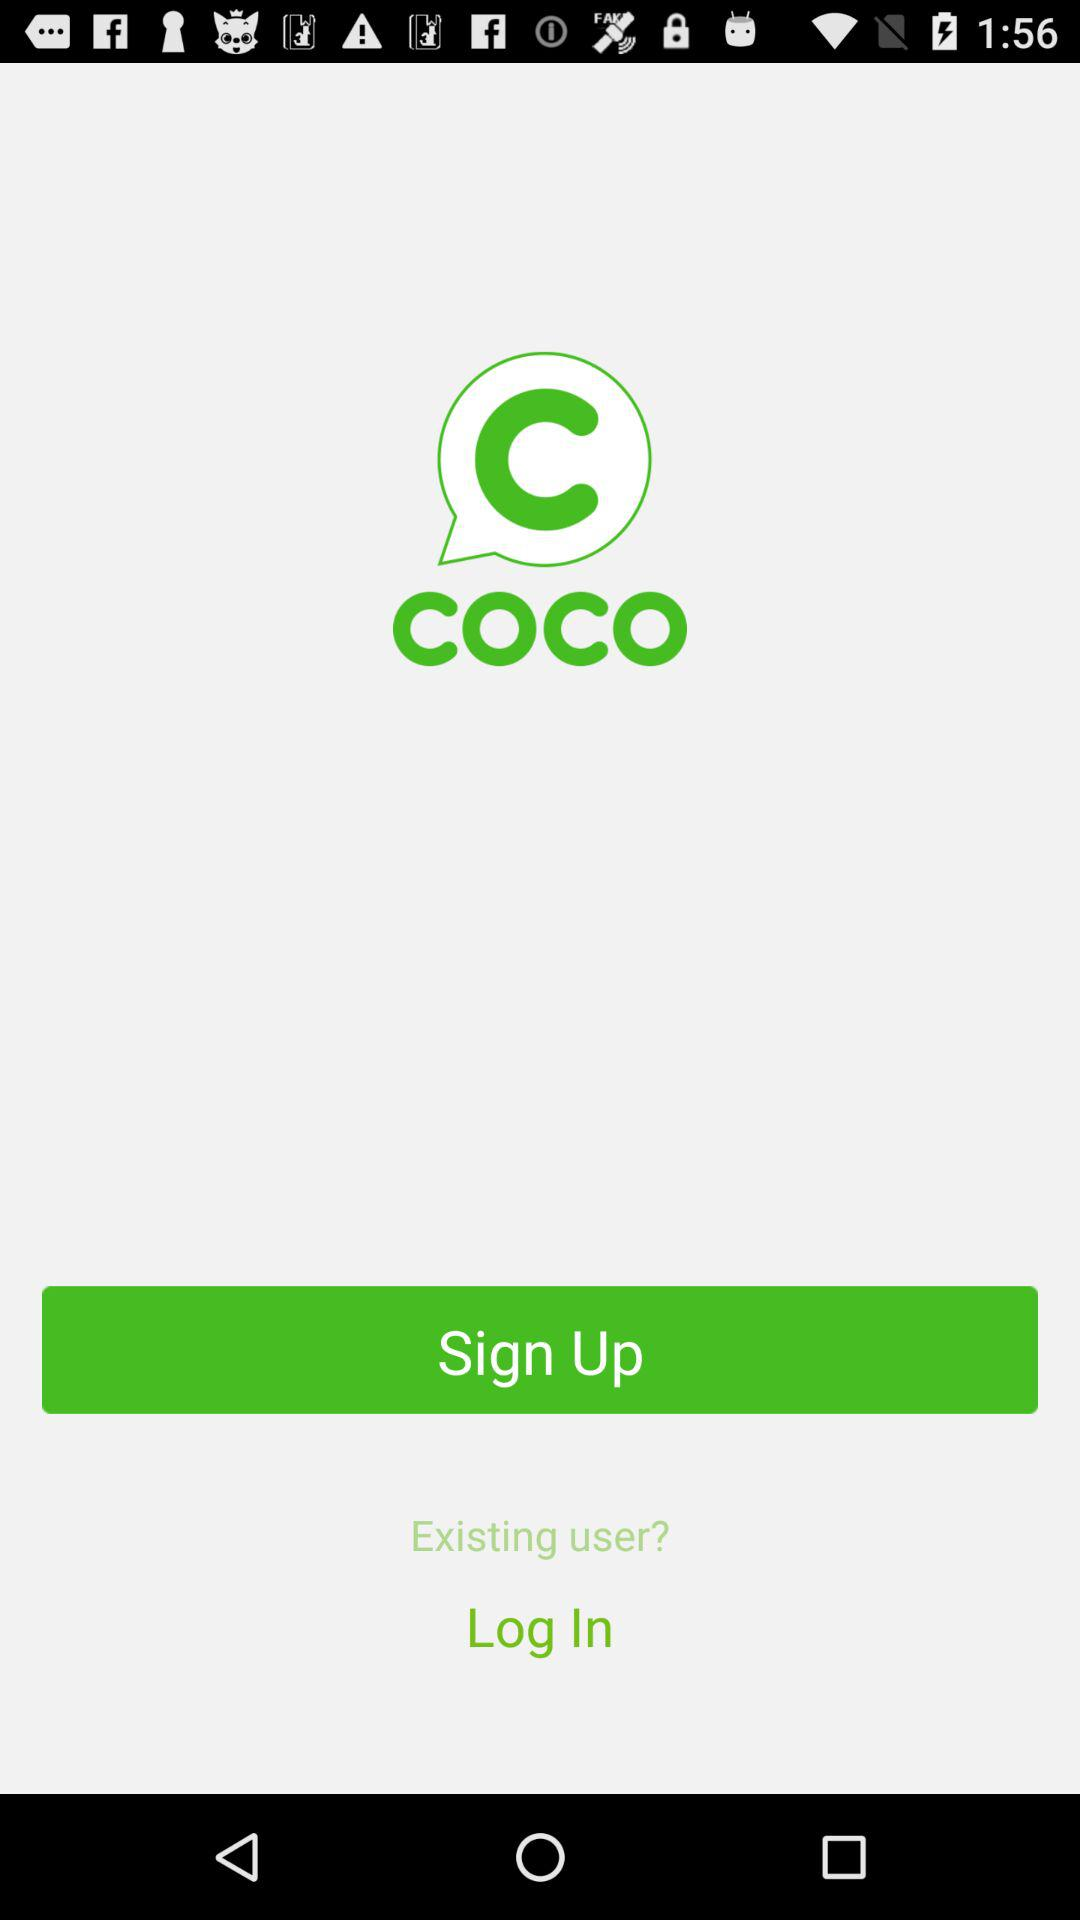Who is "coco" powered by?
When the provided information is insufficient, respond with <no answer>. <no answer> 